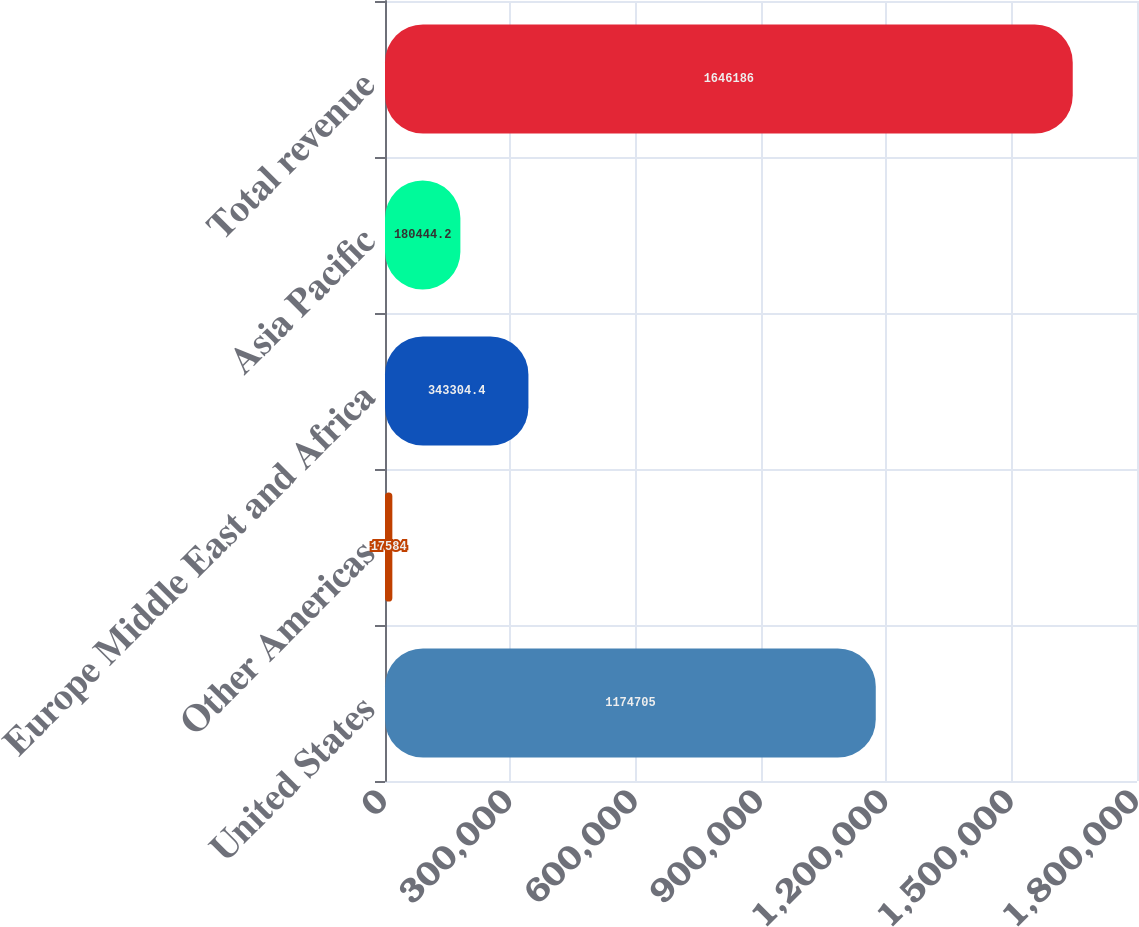Convert chart. <chart><loc_0><loc_0><loc_500><loc_500><bar_chart><fcel>United States<fcel>Other Americas<fcel>Europe Middle East and Africa<fcel>Asia Pacific<fcel>Total revenue<nl><fcel>1.1747e+06<fcel>17584<fcel>343304<fcel>180444<fcel>1.64619e+06<nl></chart> 